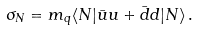Convert formula to latex. <formula><loc_0><loc_0><loc_500><loc_500>\sigma _ { N } = m _ { q } \langle N | \bar { u } u + \bar { d } d | N \rangle \, .</formula> 